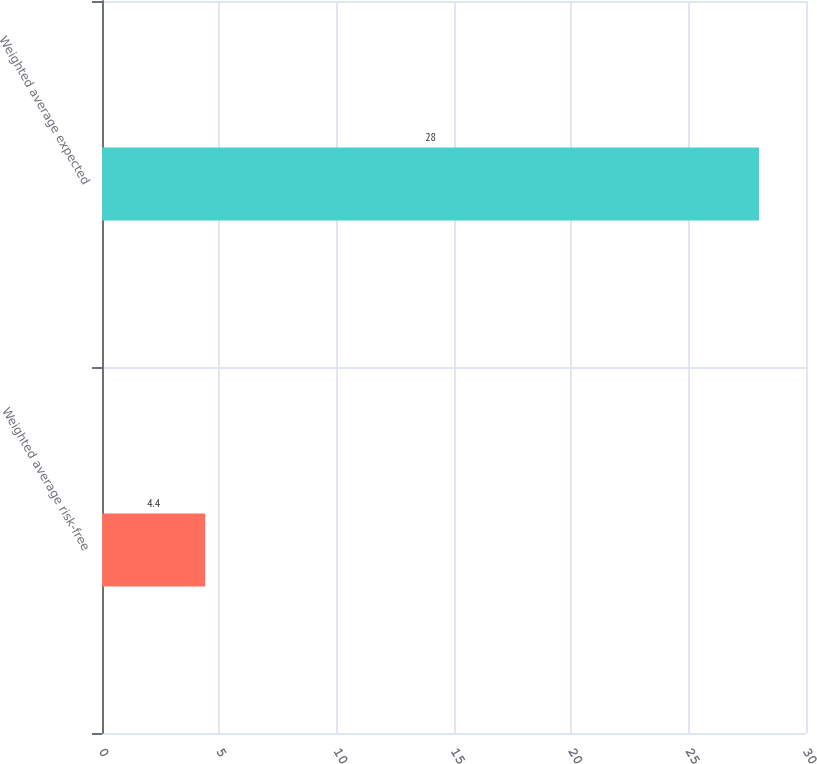<chart> <loc_0><loc_0><loc_500><loc_500><bar_chart><fcel>Weighted average risk-free<fcel>Weighted average expected<nl><fcel>4.4<fcel>28<nl></chart> 